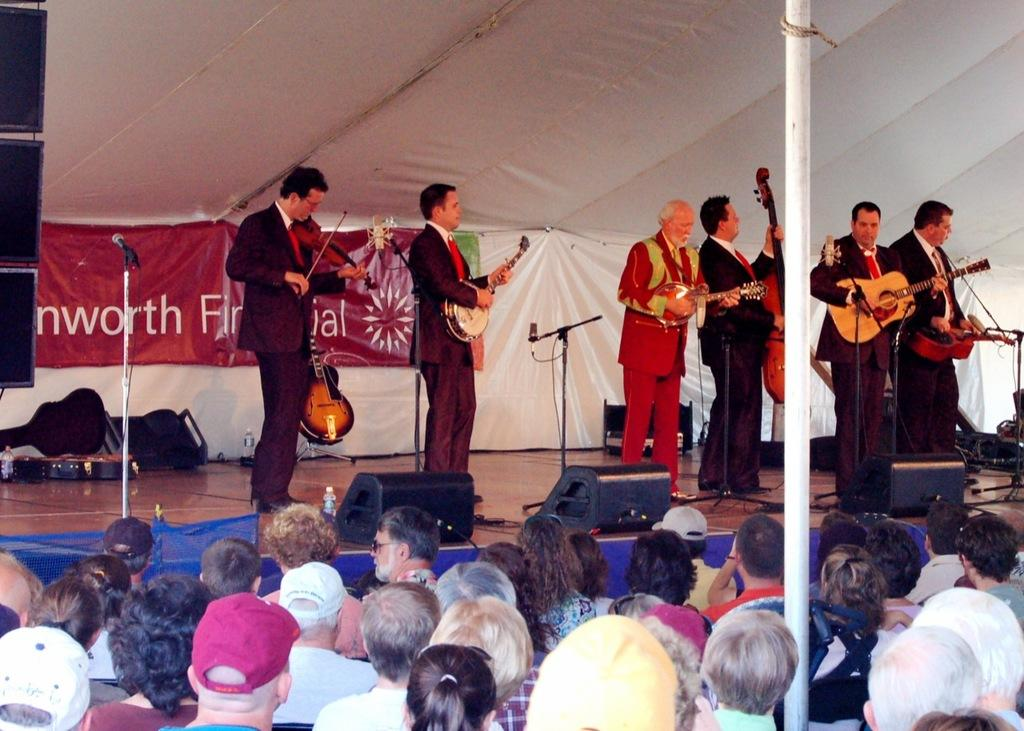What object can be seen in the image that is white in color? There is a white cloth in the image. What are the people on the stage doing? The people on stage are holding guitars. What are the people in the audience likely there to see? The people watching the stage are likely there to see the people on stage performing with their guitars. What type of government is being discussed on stage in the image? There is no discussion of government in the image; it features people on stage holding guitars and an audience watching them. What season is depicted in the image? The image does not depict a specific season; it only shows people on stage and an audience. 